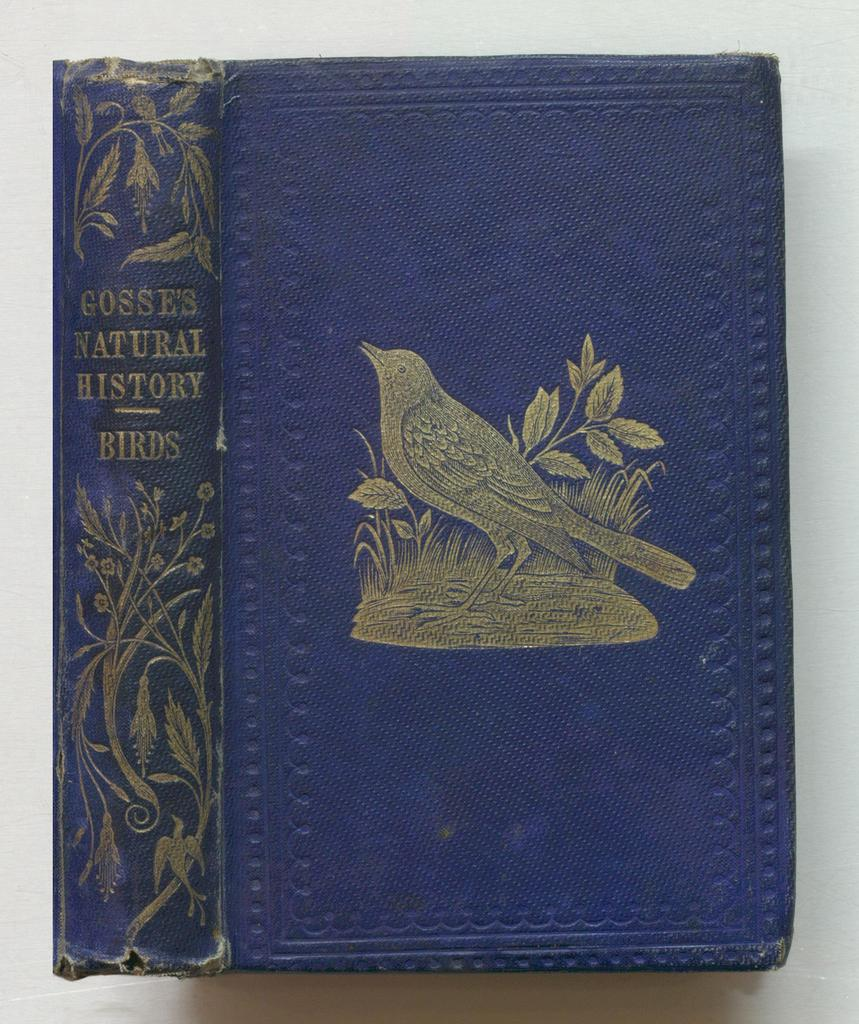Provide a one-sentence caption for the provided image. The front cover and spine of a book about birds. 